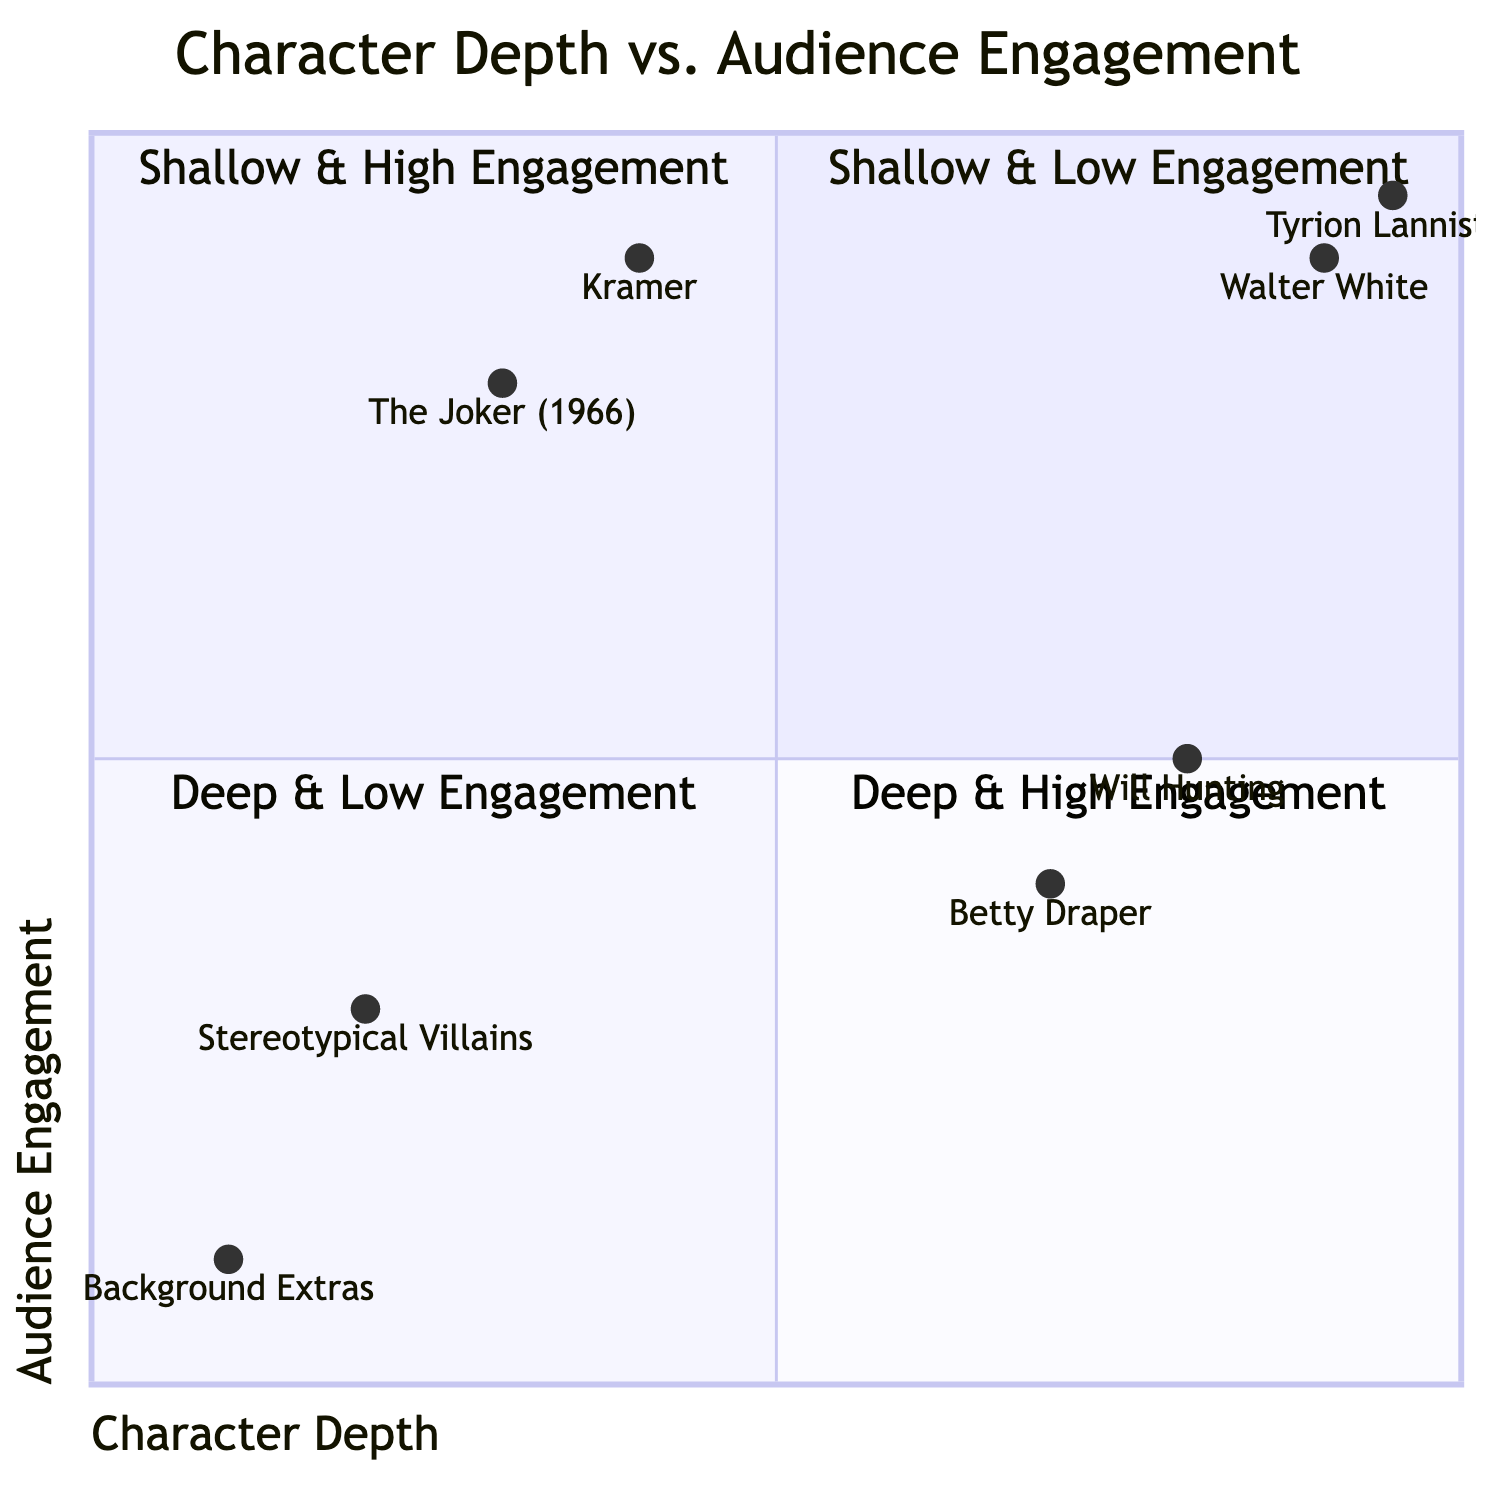What is the location of Walter White in the quadrant chart? Walter White is located in the "Deep & High Engagement" quadrant, as indicated by the coordinates [0.9, 0.9], which places him in the upper right section of the chart.
Answer: Deep & High Engagement How many characters are classified as Shallow & Low Engagement? There are two characters in the "Shallow & Low Engagement" quadrant: Background Extras and Stereotypical Villains, which means there are two characters in this category.
Answer: 2 Which character has the highest audience engagement? Tyrion Lannister has the highest audience engagement value of 0.95, as indicated by his position in the diagram.
Answer: Tyrion Lannister Which quadrant contains Betty Draper? Betty Draper is located in the "Deep & Low Engagement" quadrant, as her coordinates [0.7, 0.4] fall into this part of the chart.
Answer: Deep & Low Engagement Which character is closest to the axis of Character Depth? Background Extras, with the coordinate [0.1, 0.1], is closest to the Character Depth axis (X-axis), as it has the lowest value on the X-axis.
Answer: Background Extras How can we describe the relationship between character depth and audience engagement for characters in the 'Shallow & High Engagement' quadrant? Characters in the "Shallow & High Engagement" quadrant have low character depth but are designed to be entertaining, resulting in high audience engagement levels despite that lack of depth.
Answer: Low depth, high engagement What is the y-value of the character Kramer? The y-value of Kramer is 0.9, indicating a high level of audience engagement, which can be seen from his coordinates [0.4, 0.9].
Answer: 0.9 How many total characters are in the Deep & High Engagement quadrant? There are two characters in the "Deep & High Engagement" quadrant: Walter White and Tyrion Lannister, making a total of two characters in this classification.
Answer: 2 